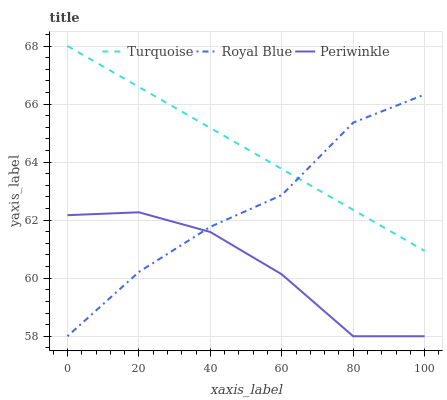Does Periwinkle have the minimum area under the curve?
Answer yes or no. Yes. Does Turquoise have the maximum area under the curve?
Answer yes or no. Yes. Does Turquoise have the minimum area under the curve?
Answer yes or no. No. Does Periwinkle have the maximum area under the curve?
Answer yes or no. No. Is Turquoise the smoothest?
Answer yes or no. Yes. Is Periwinkle the roughest?
Answer yes or no. Yes. Is Periwinkle the smoothest?
Answer yes or no. No. Is Turquoise the roughest?
Answer yes or no. No. Does Royal Blue have the lowest value?
Answer yes or no. Yes. Does Turquoise have the lowest value?
Answer yes or no. No. Does Turquoise have the highest value?
Answer yes or no. Yes. Does Periwinkle have the highest value?
Answer yes or no. No. Is Periwinkle less than Turquoise?
Answer yes or no. Yes. Is Turquoise greater than Periwinkle?
Answer yes or no. Yes. Does Periwinkle intersect Royal Blue?
Answer yes or no. Yes. Is Periwinkle less than Royal Blue?
Answer yes or no. No. Is Periwinkle greater than Royal Blue?
Answer yes or no. No. Does Periwinkle intersect Turquoise?
Answer yes or no. No. 